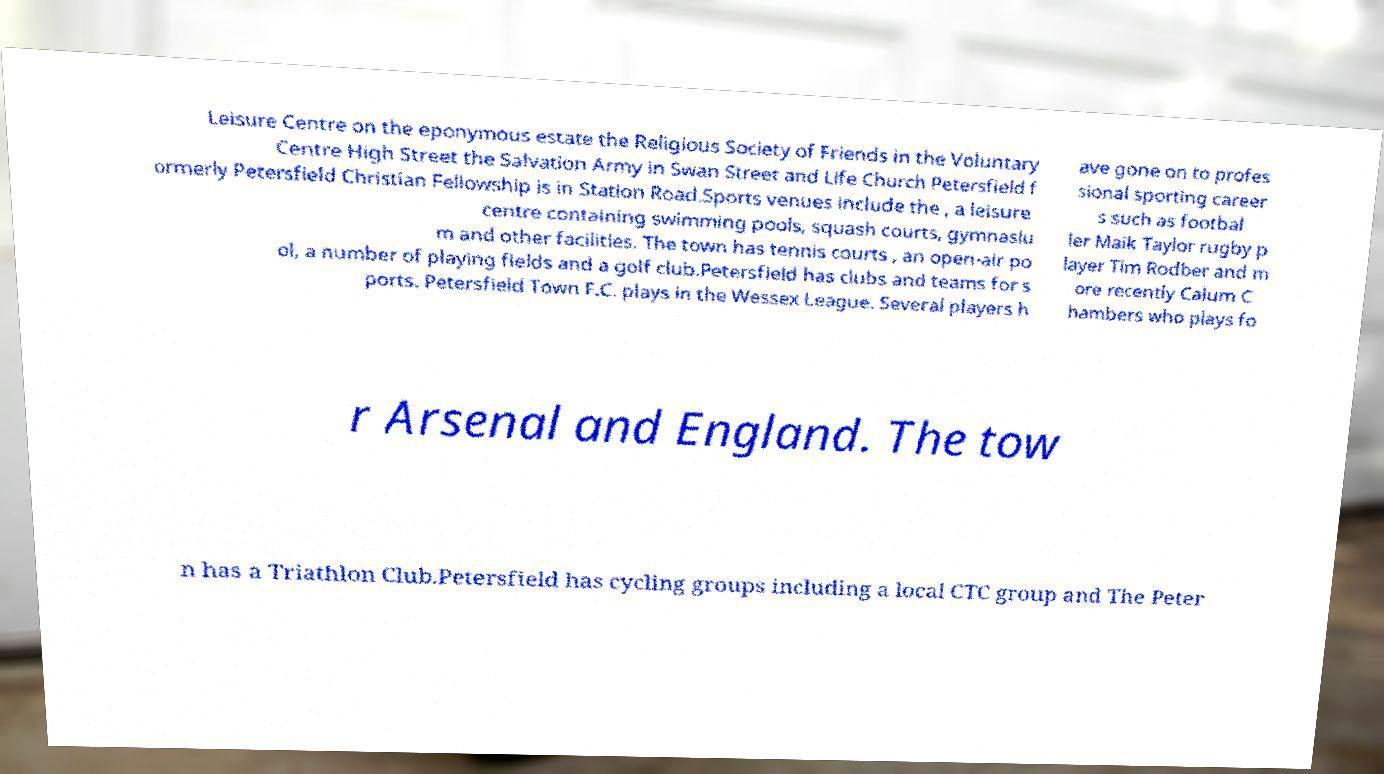For documentation purposes, I need the text within this image transcribed. Could you provide that? Leisure Centre on the eponymous estate the Religious Society of Friends in the Voluntary Centre High Street the Salvation Army in Swan Street and Life Church Petersfield f ormerly Petersfield Christian Fellowship is in Station Road.Sports venues include the , a leisure centre containing swimming pools, squash courts, gymnasiu m and other facilities. The town has tennis courts , an open-air po ol, a number of playing fields and a golf club.Petersfield has clubs and teams for s ports. Petersfield Town F.C. plays in the Wessex League. Several players h ave gone on to profes sional sporting career s such as footbal ler Maik Taylor rugby p layer Tim Rodber and m ore recently Calum C hambers who plays fo r Arsenal and England. The tow n has a Triathlon Club.Petersfield has cycling groups including a local CTC group and The Peter 